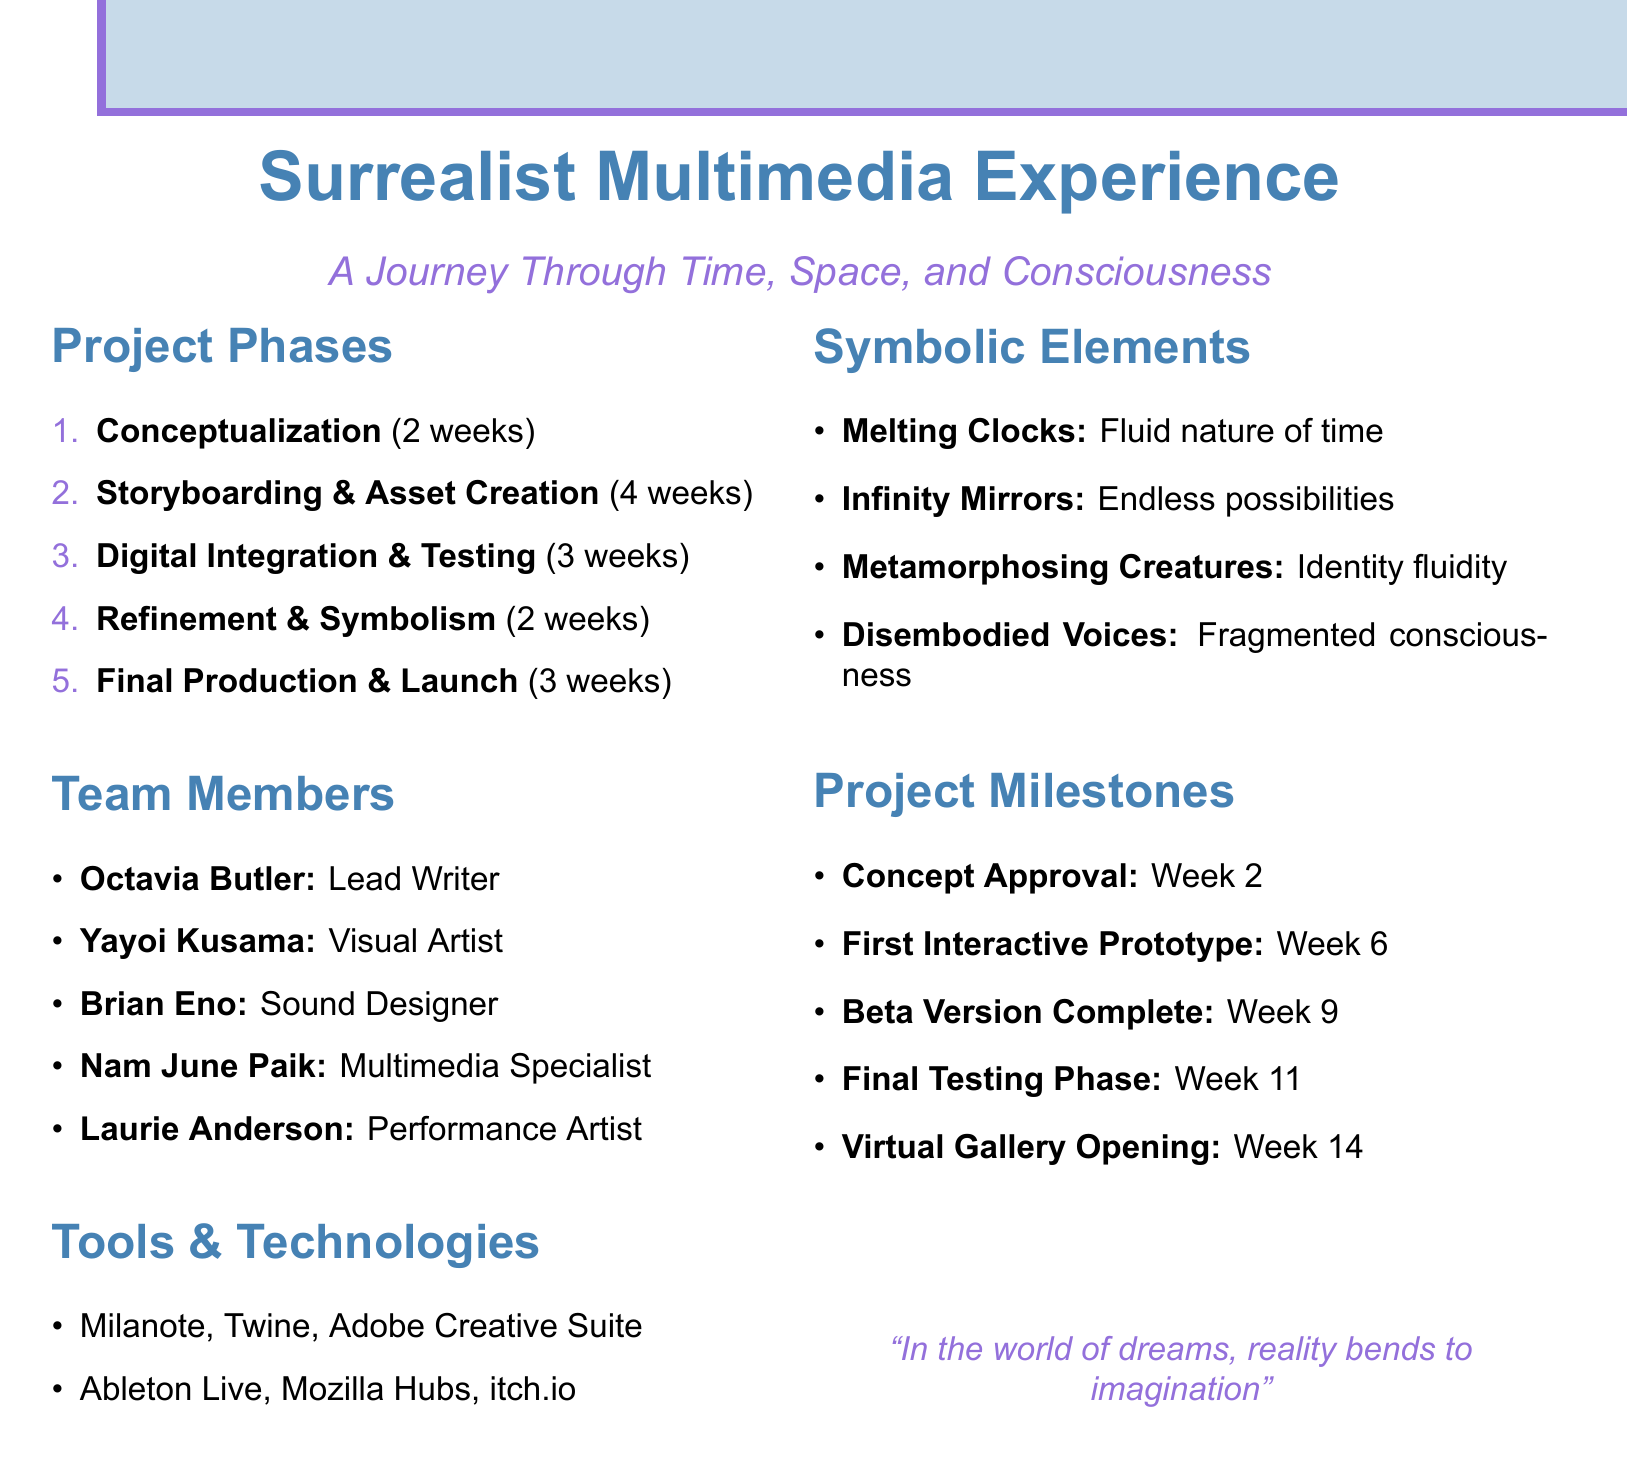What is the duration of the Conceptualization phase? The duration of the Conceptualization phase is listed in the project phases section as 2 weeks.
Answer: 2 weeks Who is the Lead Writer and Narrative Designer? The document provides a list of team members and their roles, showing that Octavia Butler is the Lead Writer and Narrative Designer.
Answer: Octavia Butler What are the two symbolic elements mentioned that feature the concept of transformation? The symbolic elements section lists both Metamorphosing Creatures and Disembodied Voices as representations of transformation.
Answer: Metamorphosing Creatures, Disembodied Voices When is the Virtual Gallery Opening scheduled? The project milestones section states that the Virtual Gallery Opening is scheduled for Week 14.
Answer: Week 14 What software will be used for sound design and music composition? The document specifies Ableton Live as the tool designated for sound design and music composition in the tools and technologies section.
Answer: Ableton Live What is one method of integrating user interaction mentioned in the document? The Digital Integration and Testing phase lists HTML5 and JavaScript as tools for implementing user interaction.
Answer: HTML5 and JavaScript What inspired the Melting Clocks symbolic element? The symbolic elements section indicates that the Melting Clocks are inspired by Salvador Dalí's "The Persistence of Memory."
Answer: Salvador Dalí's "The Persistence of Memory" How many weeks are allocated for Digital Integration and Testing? The document outlines that the duration for Digital Integration and Testing is 3 weeks according to the project phases section.
Answer: 3 weeks 